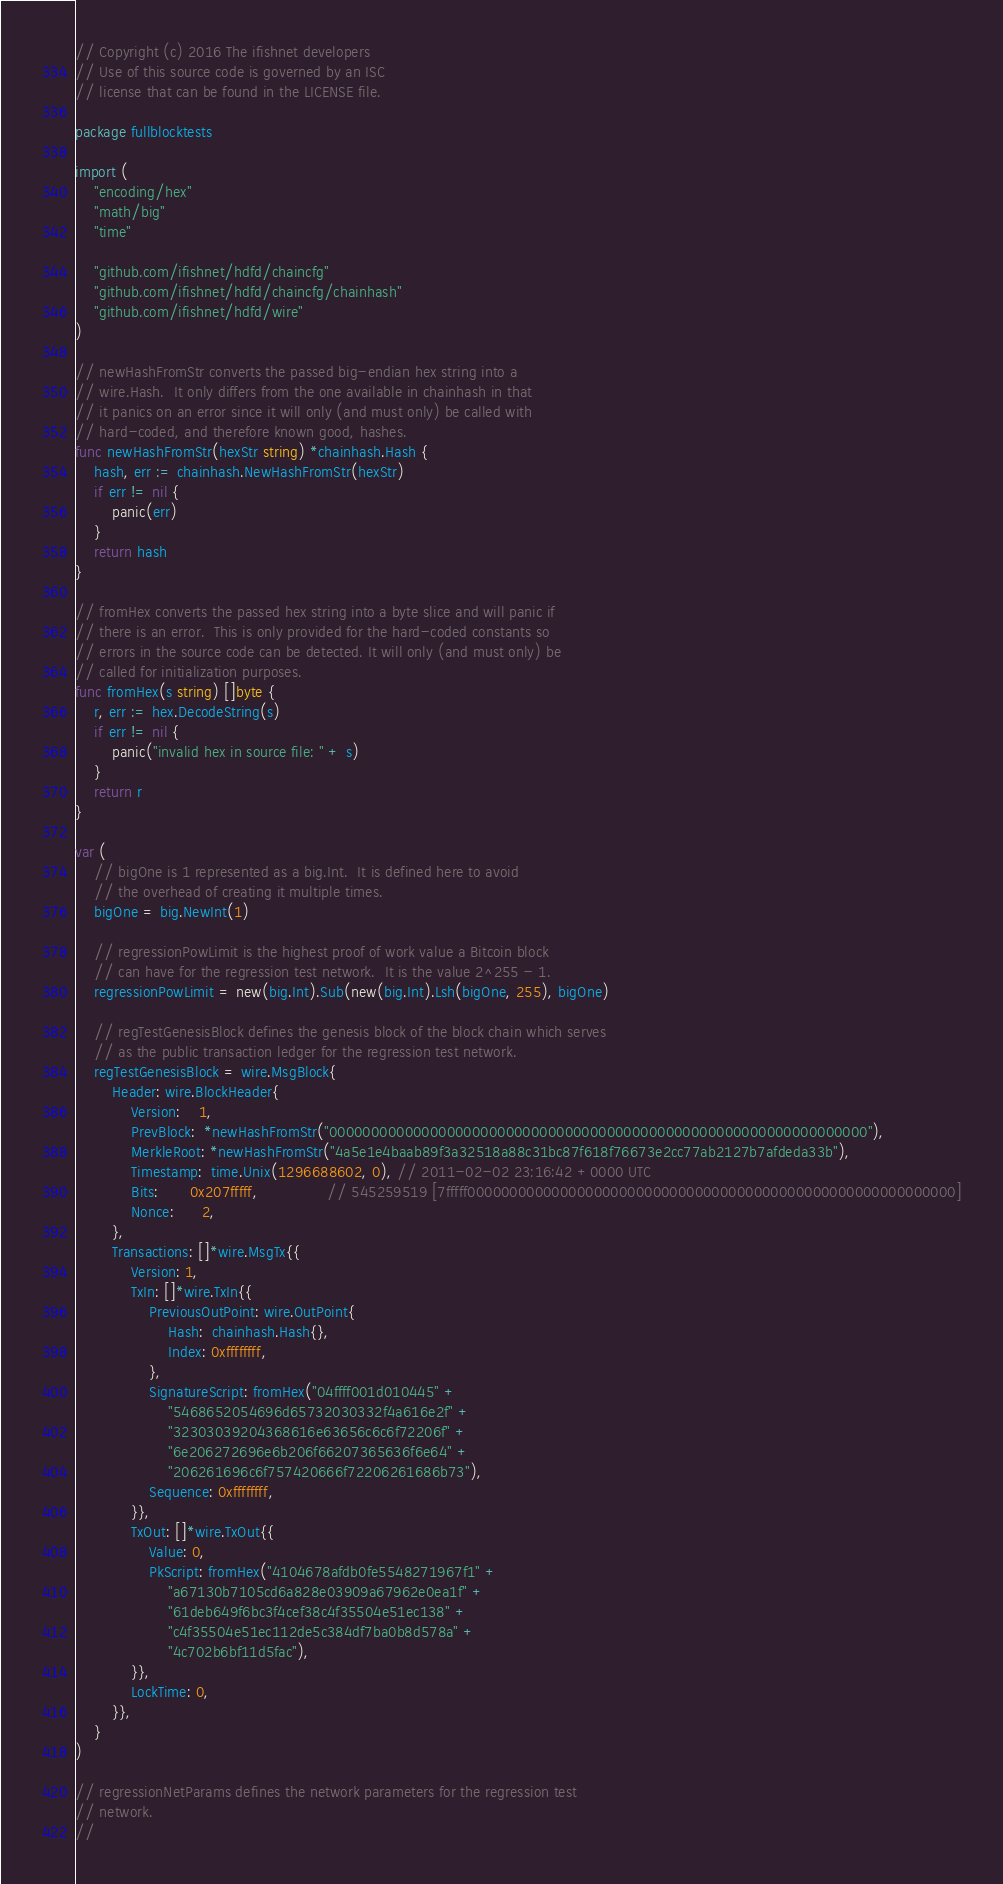<code> <loc_0><loc_0><loc_500><loc_500><_Go_>// Copyright (c) 2016 The ifishnet developers
// Use of this source code is governed by an ISC
// license that can be found in the LICENSE file.

package fullblocktests

import (
	"encoding/hex"
	"math/big"
	"time"

	"github.com/ifishnet/hdfd/chaincfg"
	"github.com/ifishnet/hdfd/chaincfg/chainhash"
	"github.com/ifishnet/hdfd/wire"
)

// newHashFromStr converts the passed big-endian hex string into a
// wire.Hash.  It only differs from the one available in chainhash in that
// it panics on an error since it will only (and must only) be called with
// hard-coded, and therefore known good, hashes.
func newHashFromStr(hexStr string) *chainhash.Hash {
	hash, err := chainhash.NewHashFromStr(hexStr)
	if err != nil {
		panic(err)
	}
	return hash
}

// fromHex converts the passed hex string into a byte slice and will panic if
// there is an error.  This is only provided for the hard-coded constants so
// errors in the source code can be detected. It will only (and must only) be
// called for initialization purposes.
func fromHex(s string) []byte {
	r, err := hex.DecodeString(s)
	if err != nil {
		panic("invalid hex in source file: " + s)
	}
	return r
}

var (
	// bigOne is 1 represented as a big.Int.  It is defined here to avoid
	// the overhead of creating it multiple times.
	bigOne = big.NewInt(1)

	// regressionPowLimit is the highest proof of work value a Bitcoin block
	// can have for the regression test network.  It is the value 2^255 - 1.
	regressionPowLimit = new(big.Int).Sub(new(big.Int).Lsh(bigOne, 255), bigOne)

	// regTestGenesisBlock defines the genesis block of the block chain which serves
	// as the public transaction ledger for the regression test network.
	regTestGenesisBlock = wire.MsgBlock{
		Header: wire.BlockHeader{
			Version:    1,
			PrevBlock:  *newHashFromStr("0000000000000000000000000000000000000000000000000000000000000000"),
			MerkleRoot: *newHashFromStr("4a5e1e4baab89f3a32518a88c31bc87f618f76673e2cc77ab2127b7afdeda33b"),
			Timestamp:  time.Unix(1296688602, 0), // 2011-02-02 23:16:42 +0000 UTC
			Bits:       0x207fffff,               // 545259519 [7fffff0000000000000000000000000000000000000000000000000000000000]
			Nonce:      2,
		},
		Transactions: []*wire.MsgTx{{
			Version: 1,
			TxIn: []*wire.TxIn{{
				PreviousOutPoint: wire.OutPoint{
					Hash:  chainhash.Hash{},
					Index: 0xffffffff,
				},
				SignatureScript: fromHex("04ffff001d010445" +
					"5468652054696d65732030332f4a616e2f" +
					"32303039204368616e63656c6c6f72206f" +
					"6e206272696e6b206f66207365636f6e64" +
					"206261696c6f757420666f72206261686b73"),
				Sequence: 0xffffffff,
			}},
			TxOut: []*wire.TxOut{{
				Value: 0,
				PkScript: fromHex("4104678afdb0fe5548271967f1" +
					"a67130b7105cd6a828e03909a67962e0ea1f" +
					"61deb649f6bc3f4cef38c4f35504e51ec138" +
					"c4f35504e51ec112de5c384df7ba0b8d578a" +
					"4c702b6bf11d5fac"),
			}},
			LockTime: 0,
		}},
	}
)

// regressionNetParams defines the network parameters for the regression test
// network.
//</code> 